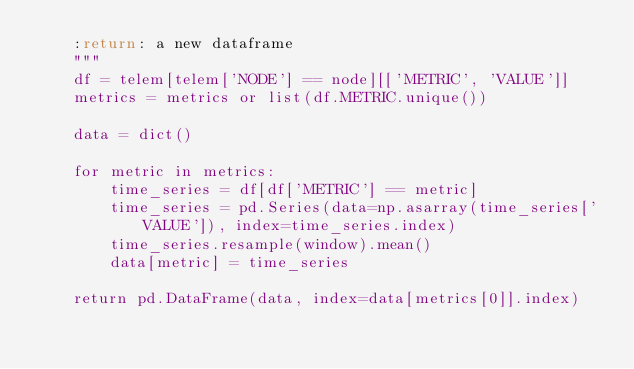Convert code to text. <code><loc_0><loc_0><loc_500><loc_500><_Python_>    :return: a new dataframe
    """
    df = telem[telem['NODE'] == node][['METRIC', 'VALUE']]
    metrics = metrics or list(df.METRIC.unique())

    data = dict()

    for metric in metrics:
        time_series = df[df['METRIC'] == metric]
        time_series = pd.Series(data=np.asarray(time_series['VALUE']), index=time_series.index)
        time_series.resample(window).mean()
        data[metric] = time_series

    return pd.DataFrame(data, index=data[metrics[0]].index)
</code> 